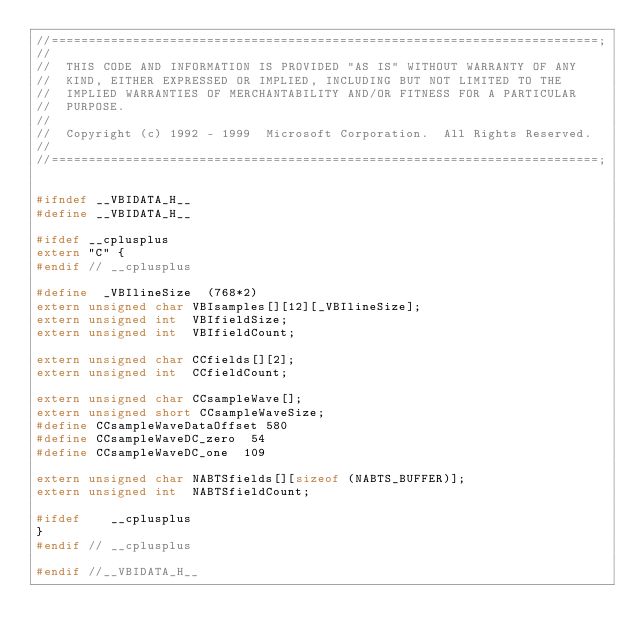Convert code to text. <code><loc_0><loc_0><loc_500><loc_500><_C_>//==========================================================================;
//
//  THIS CODE AND INFORMATION IS PROVIDED "AS IS" WITHOUT WARRANTY OF ANY
//  KIND, EITHER EXPRESSED OR IMPLIED, INCLUDING BUT NOT LIMITED TO THE
//  IMPLIED WARRANTIES OF MERCHANTABILITY AND/OR FITNESS FOR A PARTICULAR
//  PURPOSE.
//
//  Copyright (c) 1992 - 1999  Microsoft Corporation.  All Rights Reserved.
//
//==========================================================================;


#ifndef __VBIDATA_H__
#define __VBIDATA_H__

#ifdef __cplusplus
extern "C" {
#endif // __cplusplus

#define  _VBIlineSize  (768*2)
extern unsigned char VBIsamples[][12][_VBIlineSize];
extern unsigned int  VBIfieldSize;
extern unsigned int  VBIfieldCount;

extern unsigned char CCfields[][2];
extern unsigned int  CCfieldCount;

extern unsigned char CCsampleWave[];
extern unsigned short CCsampleWaveSize;
#define CCsampleWaveDataOffset 580
#define CCsampleWaveDC_zero  54
#define CCsampleWaveDC_one  109

extern unsigned char NABTSfields[][sizeof (NABTS_BUFFER)];
extern unsigned int  NABTSfieldCount;

#ifdef    __cplusplus
}
#endif // __cplusplus

#endif //__VBIDATA_H__
</code> 